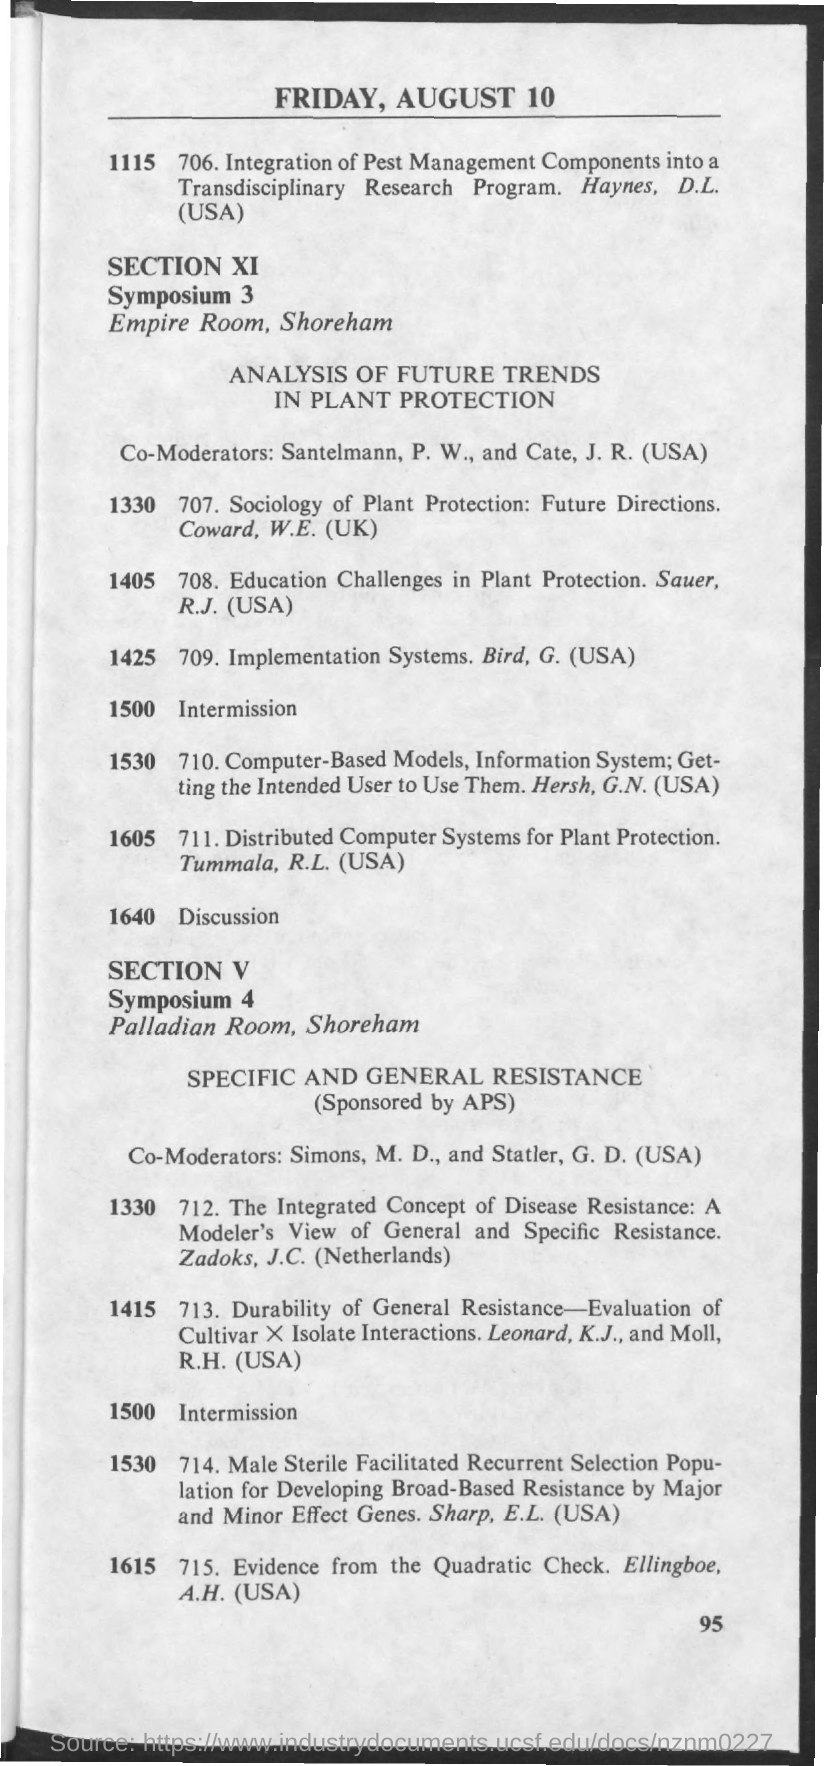Mention a couple of crucial points in this snapshot. The date mentioned in the given page is Friday, August 10. The Empire Room is the name of the room that was mentioned in connection with Symposium 3. At 1500 in Symposium 4, there is an intermission. The name of the room mentioned for symposium 4 is Palladian. The schedule at 1500 in Symposium 3 is intermission. 